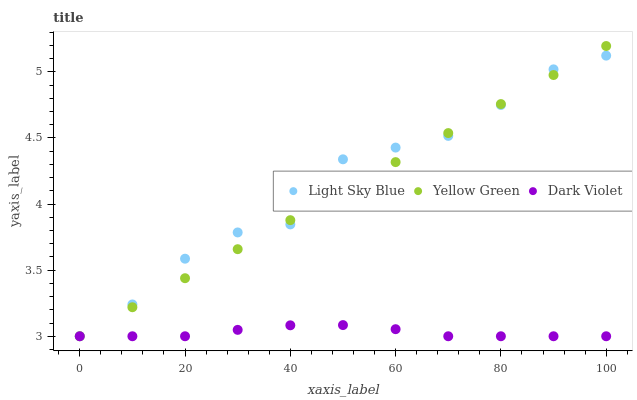Does Dark Violet have the minimum area under the curve?
Answer yes or no. Yes. Does Light Sky Blue have the maximum area under the curve?
Answer yes or no. Yes. Does Yellow Green have the minimum area under the curve?
Answer yes or no. No. Does Yellow Green have the maximum area under the curve?
Answer yes or no. No. Is Yellow Green the smoothest?
Answer yes or no. Yes. Is Light Sky Blue the roughest?
Answer yes or no. Yes. Is Dark Violet the smoothest?
Answer yes or no. No. Is Dark Violet the roughest?
Answer yes or no. No. Does Light Sky Blue have the lowest value?
Answer yes or no. Yes. Does Yellow Green have the highest value?
Answer yes or no. Yes. Does Dark Violet have the highest value?
Answer yes or no. No. Does Light Sky Blue intersect Yellow Green?
Answer yes or no. Yes. Is Light Sky Blue less than Yellow Green?
Answer yes or no. No. Is Light Sky Blue greater than Yellow Green?
Answer yes or no. No. 